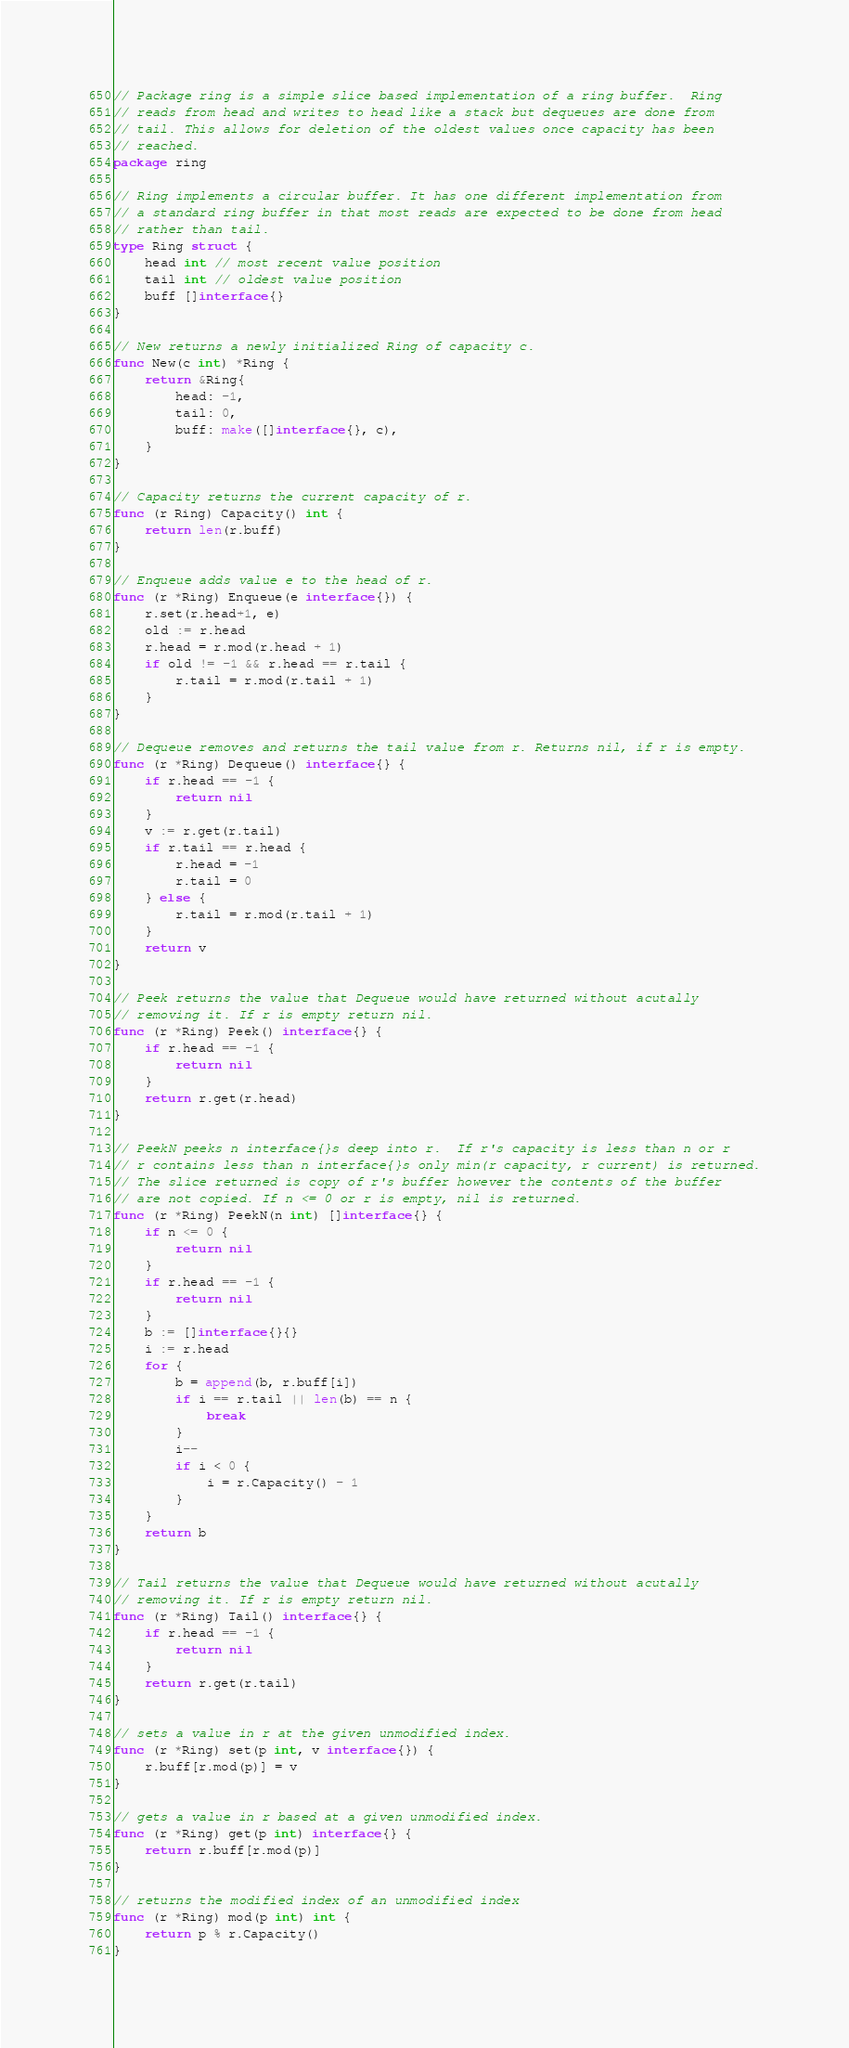<code> <loc_0><loc_0><loc_500><loc_500><_Go_>// Package ring is a simple slice based implementation of a ring buffer.  Ring
// reads from head and writes to head like a stack but dequeues are done from
// tail. This allows for deletion of the oldest values once capacity has been
// reached.
package ring

// Ring implements a circular buffer. It has one different implementation from
// a standard ring buffer in that most reads are expected to be done from head
// rather than tail.
type Ring struct {
	head int // most recent value position
	tail int // oldest value position
	buff []interface{}
}

// New returns a newly initialized Ring of capacity c.
func New(c int) *Ring {
	return &Ring{
		head: -1,
		tail: 0,
		buff: make([]interface{}, c),
	}
}

// Capacity returns the current capacity of r.
func (r Ring) Capacity() int {
	return len(r.buff)
}

// Enqueue adds value e to the head of r.
func (r *Ring) Enqueue(e interface{}) {
	r.set(r.head+1, e)
	old := r.head
	r.head = r.mod(r.head + 1)
	if old != -1 && r.head == r.tail {
		r.tail = r.mod(r.tail + 1)
	}
}

// Dequeue removes and returns the tail value from r. Returns nil, if r is empty.
func (r *Ring) Dequeue() interface{} {
	if r.head == -1 {
		return nil
	}
	v := r.get(r.tail)
	if r.tail == r.head {
		r.head = -1
		r.tail = 0
	} else {
		r.tail = r.mod(r.tail + 1)
	}
	return v
}

// Peek returns the value that Dequeue would have returned without acutally
// removing it. If r is empty return nil.
func (r *Ring) Peek() interface{} {
	if r.head == -1 {
		return nil
	}
	return r.get(r.head)
}

// PeekN peeks n interface{}s deep into r.  If r's capacity is less than n or r
// r contains less than n interface{}s only min(r capacity, r current) is returned.
// The slice returned is copy of r's buffer however the contents of the buffer
// are not copied. If n <= 0 or r is empty, nil is returned.
func (r *Ring) PeekN(n int) []interface{} {
	if n <= 0 {
		return nil
	}
	if r.head == -1 {
		return nil
	}
	b := []interface{}{}
	i := r.head
	for {
		b = append(b, r.buff[i])
		if i == r.tail || len(b) == n {
			break
		}
		i--
		if i < 0 {
			i = r.Capacity() - 1
		}
	}
	return b
}

// Tail returns the value that Dequeue would have returned without acutally
// removing it. If r is empty return nil.
func (r *Ring) Tail() interface{} {
	if r.head == -1 {
		return nil
	}
	return r.get(r.tail)
}

// sets a value in r at the given unmodified index.
func (r *Ring) set(p int, v interface{}) {
	r.buff[r.mod(p)] = v
}

// gets a value in r based at a given unmodified index.
func (r *Ring) get(p int) interface{} {
	return r.buff[r.mod(p)]
}

// returns the modified index of an unmodified index
func (r *Ring) mod(p int) int {
	return p % r.Capacity()
}
</code> 